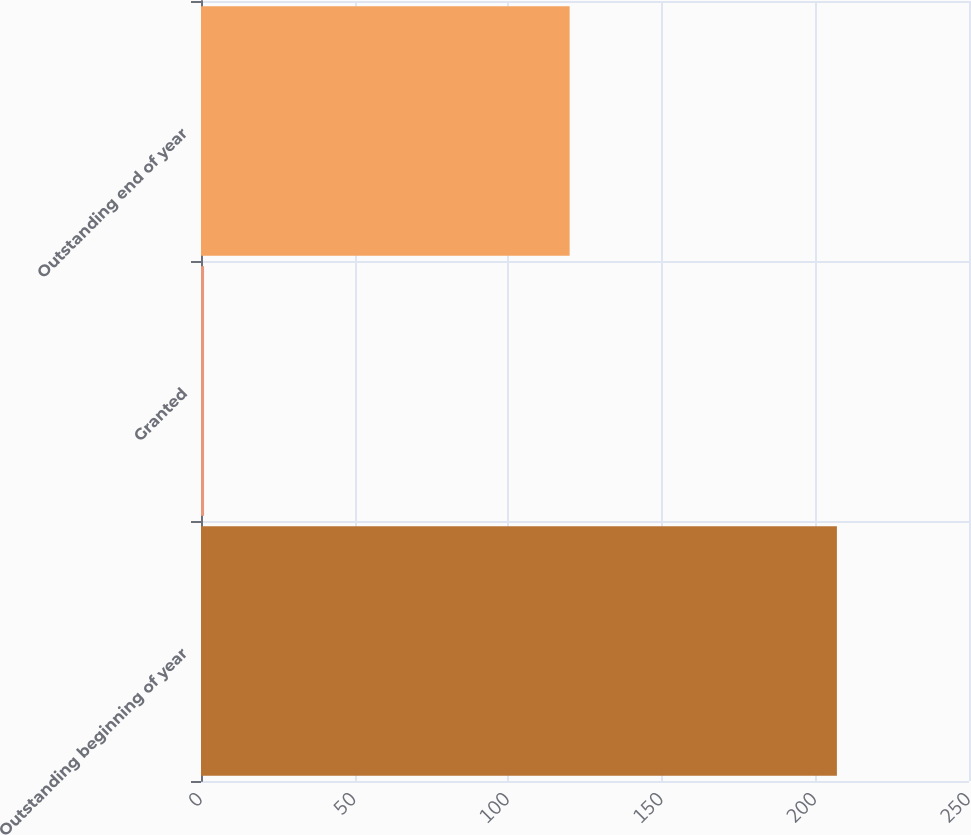Convert chart to OTSL. <chart><loc_0><loc_0><loc_500><loc_500><bar_chart><fcel>Outstanding beginning of year<fcel>Granted<fcel>Outstanding end of year<nl><fcel>207<fcel>1<fcel>120<nl></chart> 